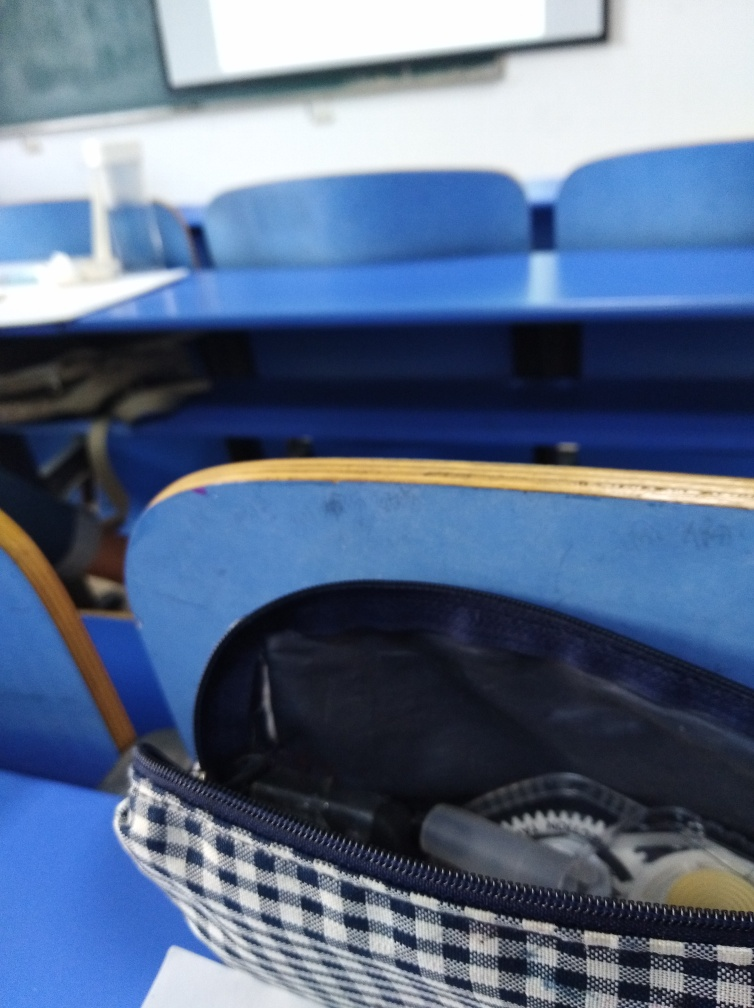Can you describe the items inside the pencil case? The pencil case contains a variety of writing implements, including what appears to be pens and pencils, hinting at the preparedness of a student for note-taking or writing tasks. Do the items look well-maintained or used? The items give the impression of being frequently used, reflecting a student's active engagement with their studies and coursework. 